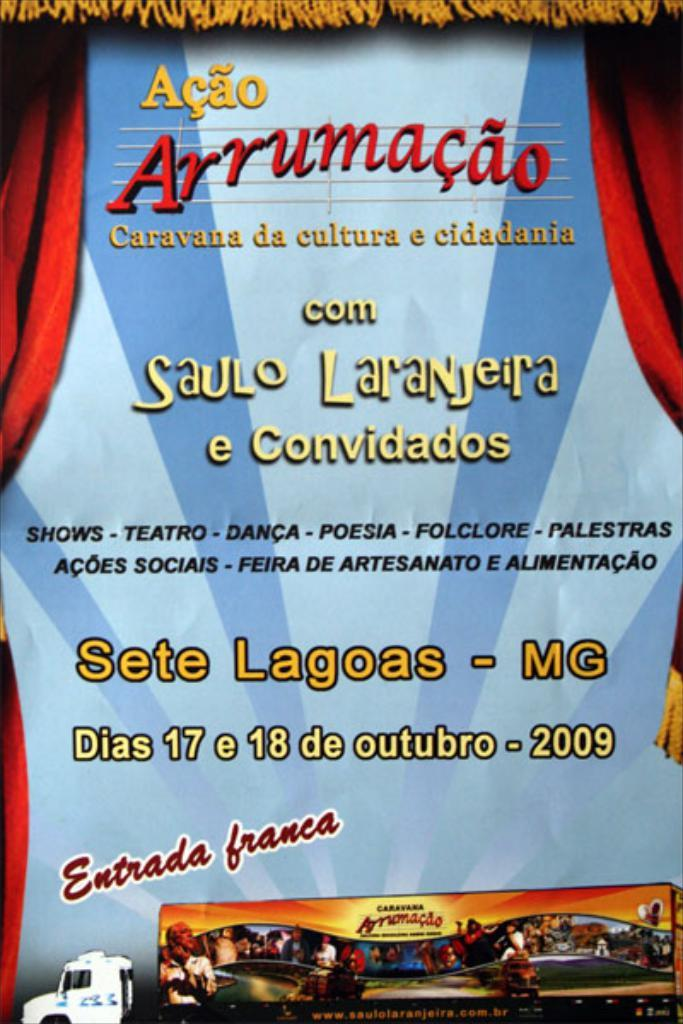<image>
Give a short and clear explanation of the subsequent image. An advertisement for a performance that will take place in 2009. 